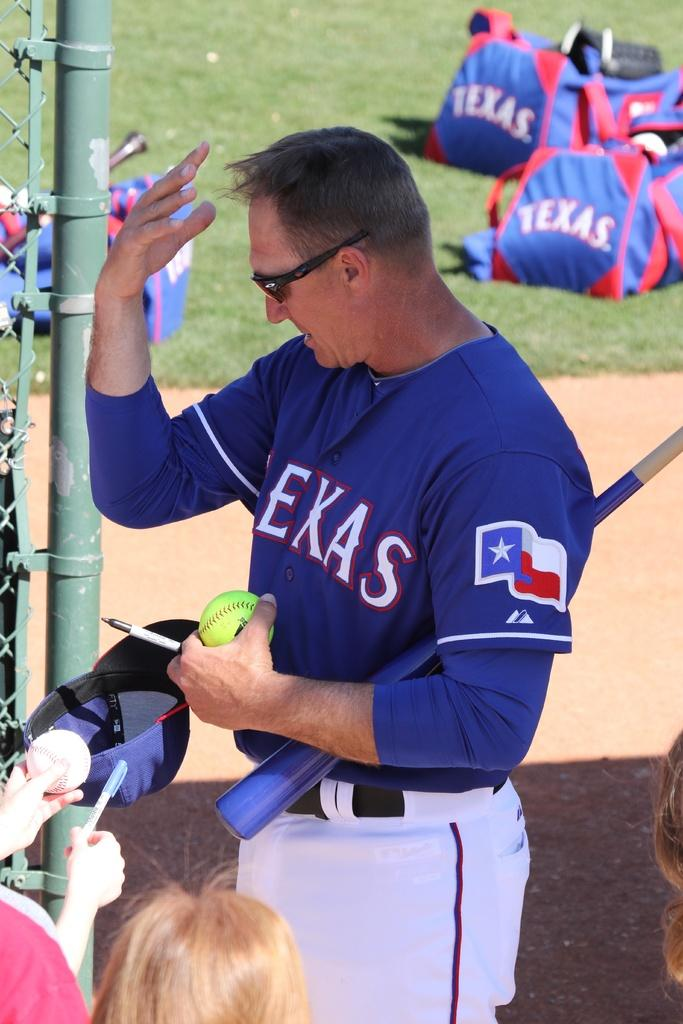<image>
Summarize the visual content of the image. A ball player in a blue Texas shirt signs autographs for fans. 